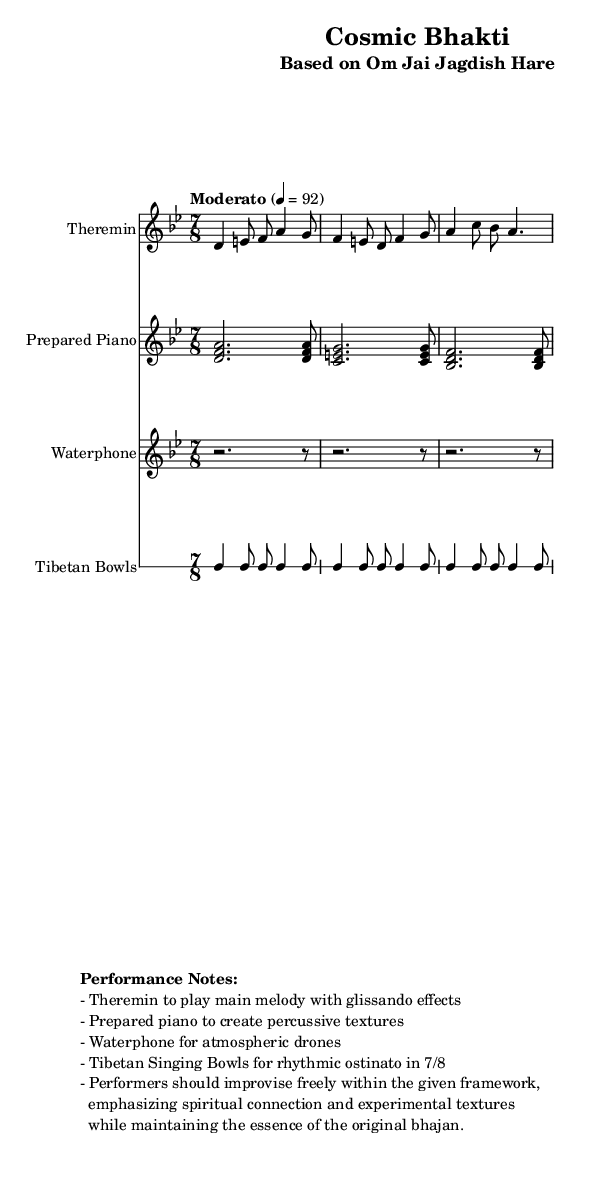What is the key signature of this music? The key signature is indicated at the beginning of the piece. In this case, it is marked as "d", which refers to the D Phrygian scale.
Answer: D Phrygian What is the time signature of the music? The time signature is shown at the start of the score. It is "7/8", which indicates there are seven beats in each measure, with the eighth note as the smallest unit.
Answer: 7/8 What is the tempo marking for the piece? The tempo is specified directly in the score, indicated as "Moderato" followed by "4 = 92", which means the quarter note is the beat and should be played at 92 beats per minute.
Answer: Moderato, 4 = 92 Which instrument plays the main melody? The main melody is highlighted at the beginning, where the "Theremin" is specified as the instrument for this voice. The score indicates that the Theremin plays the primary melodic line.
Answer: Theremin How many times is the 'r' rest repeated in the Waterphone part? The Waterphone part has a section that indicates to "repeat unfold 3" for the rests, meaning the rest is intended to be played three times in succession.
Answer: 3 What is the rhythmic ostinato instrument used in the score? The Tibetan Bowls are explicitly noted to perform a rhythmic ostinato, which is a repeated pattern, in the score. This designation is indicated right at the beginning of the Tibetan Bowls' section.
Answer: Tibetan Bowls What should performers emphasize during their improvisation? The performance notes detail that improvisation should focus on emphasizing "spiritual connection and experimental textures," which is a central theme noted for the performers' approach.
Answer: Spiritual connection and experimental textures 